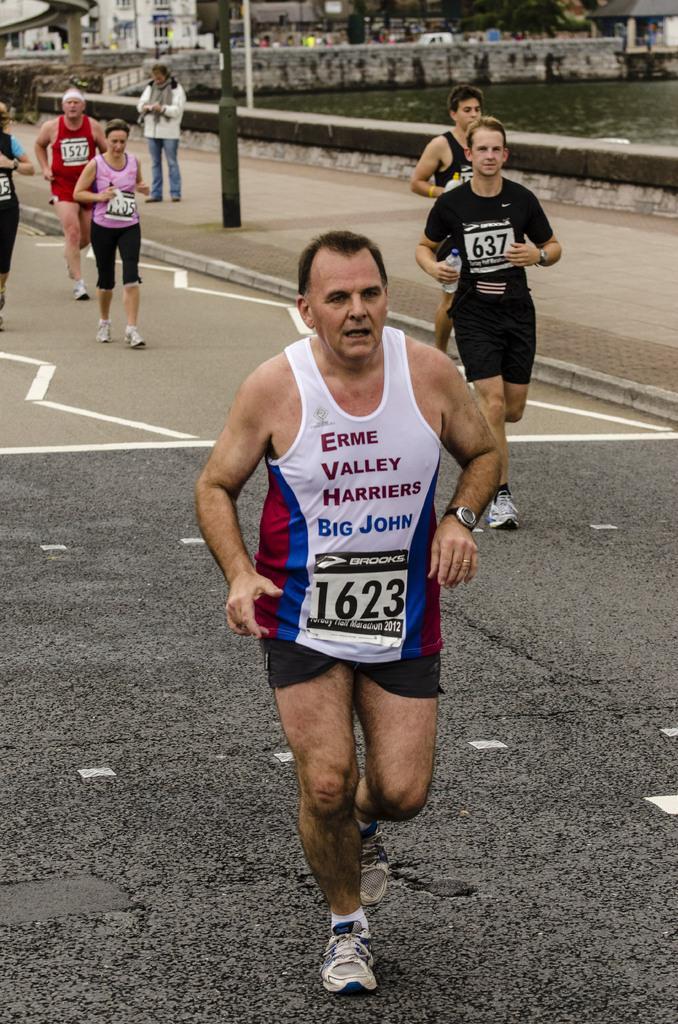Describe this image in one or two sentences. In this picture I can see some people are running on the road. Among them some are wearing t-shirts and some are wearing tank tops and shorts. In the background I can see water, poles and buildings. 